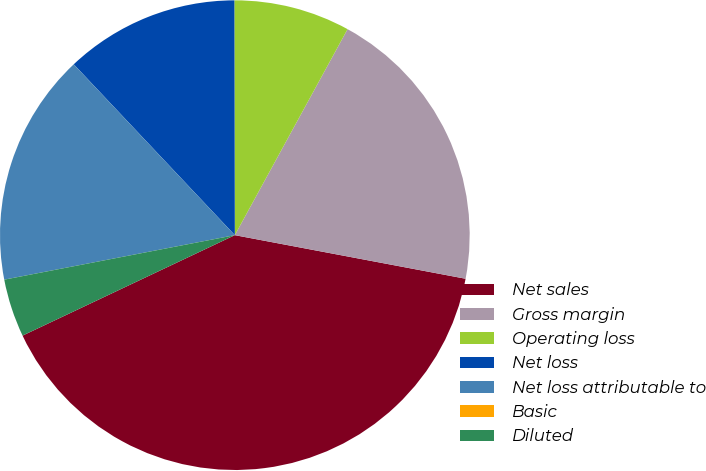<chart> <loc_0><loc_0><loc_500><loc_500><pie_chart><fcel>Net sales<fcel>Gross margin<fcel>Operating loss<fcel>Net loss<fcel>Net loss attributable to<fcel>Basic<fcel>Diluted<nl><fcel>39.99%<fcel>20.0%<fcel>8.0%<fcel>12.0%<fcel>16.0%<fcel>0.0%<fcel>4.0%<nl></chart> 